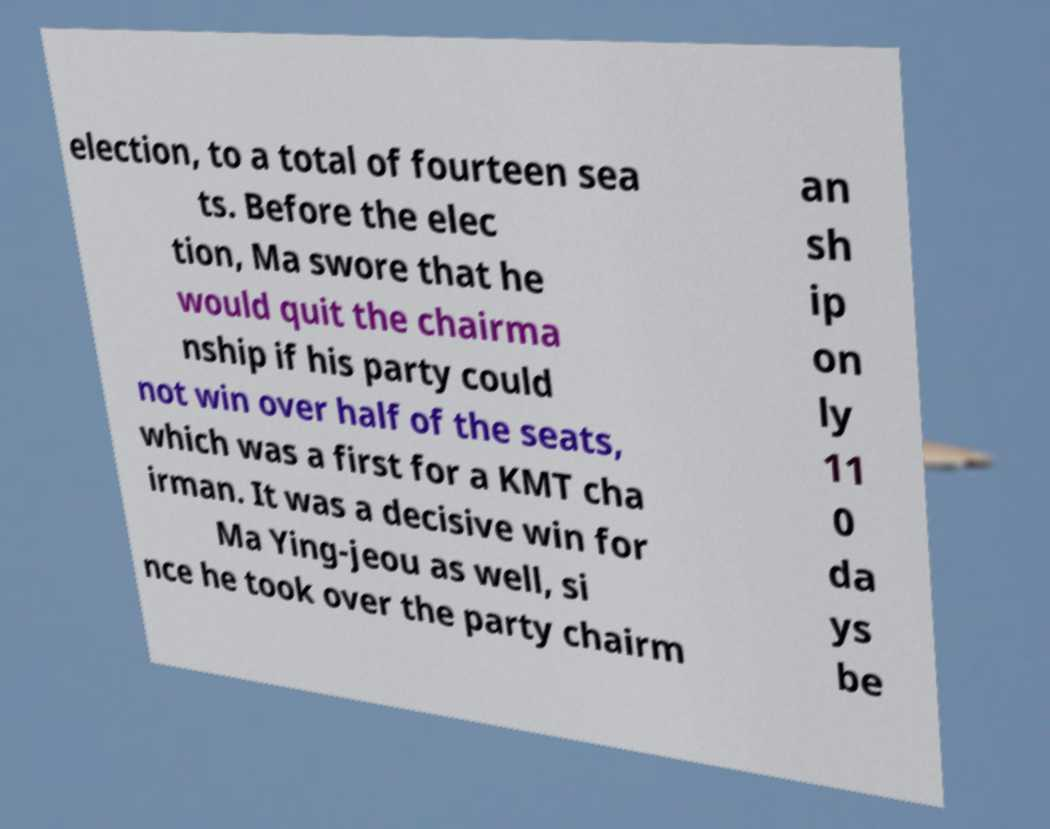Could you extract and type out the text from this image? election, to a total of fourteen sea ts. Before the elec tion, Ma swore that he would quit the chairma nship if his party could not win over half of the seats, which was a first for a KMT cha irman. It was a decisive win for Ma Ying-jeou as well, si nce he took over the party chairm an sh ip on ly 11 0 da ys be 